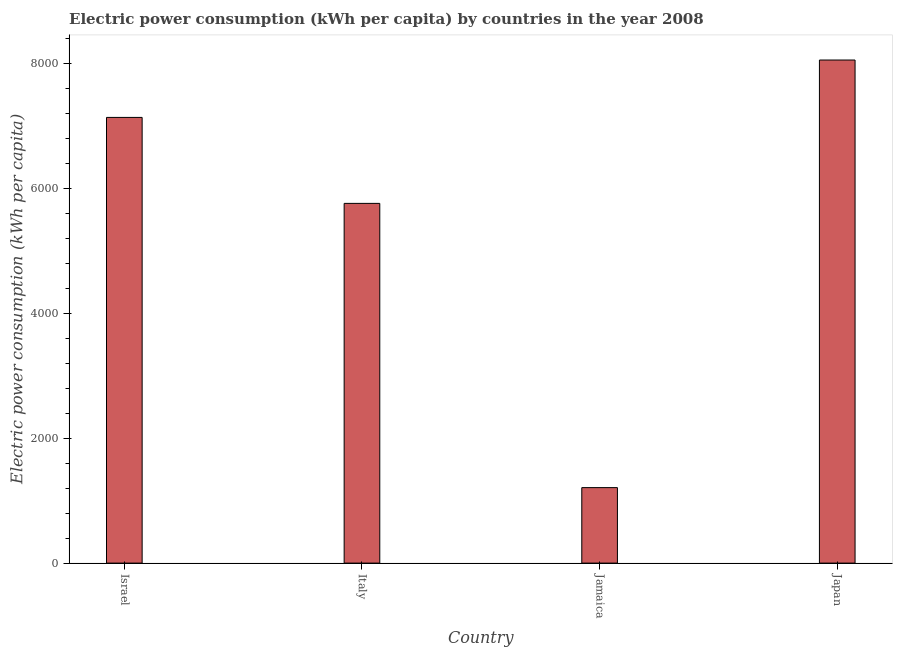Does the graph contain grids?
Keep it short and to the point. No. What is the title of the graph?
Give a very brief answer. Electric power consumption (kWh per capita) by countries in the year 2008. What is the label or title of the Y-axis?
Ensure brevity in your answer.  Electric power consumption (kWh per capita). What is the electric power consumption in Japan?
Keep it short and to the point. 8052.58. Across all countries, what is the maximum electric power consumption?
Provide a succinct answer. 8052.58. Across all countries, what is the minimum electric power consumption?
Offer a terse response. 1208.11. In which country was the electric power consumption minimum?
Provide a short and direct response. Jamaica. What is the sum of the electric power consumption?
Give a very brief answer. 2.22e+04. What is the difference between the electric power consumption in Israel and Italy?
Make the answer very short. 1376.06. What is the average electric power consumption per country?
Your answer should be compact. 5538.16. What is the median electric power consumption?
Offer a terse response. 6445.97. In how many countries, is the electric power consumption greater than 6400 kWh per capita?
Make the answer very short. 2. What is the ratio of the electric power consumption in Israel to that in Jamaica?
Your response must be concise. 5.91. Is the difference between the electric power consumption in Italy and Jamaica greater than the difference between any two countries?
Your answer should be compact. No. What is the difference between the highest and the second highest electric power consumption?
Offer a very short reply. 918.57. Is the sum of the electric power consumption in Israel and Japan greater than the maximum electric power consumption across all countries?
Keep it short and to the point. Yes. What is the difference between the highest and the lowest electric power consumption?
Ensure brevity in your answer.  6844.46. In how many countries, is the electric power consumption greater than the average electric power consumption taken over all countries?
Your answer should be very brief. 3. How many bars are there?
Your response must be concise. 4. Are all the bars in the graph horizontal?
Give a very brief answer. No. How many countries are there in the graph?
Offer a very short reply. 4. What is the difference between two consecutive major ticks on the Y-axis?
Give a very brief answer. 2000. What is the Electric power consumption (kWh per capita) of Israel?
Keep it short and to the point. 7134. What is the Electric power consumption (kWh per capita) in Italy?
Provide a short and direct response. 5757.94. What is the Electric power consumption (kWh per capita) in Jamaica?
Keep it short and to the point. 1208.11. What is the Electric power consumption (kWh per capita) of Japan?
Give a very brief answer. 8052.58. What is the difference between the Electric power consumption (kWh per capita) in Israel and Italy?
Provide a short and direct response. 1376.06. What is the difference between the Electric power consumption (kWh per capita) in Israel and Jamaica?
Offer a very short reply. 5925.89. What is the difference between the Electric power consumption (kWh per capita) in Israel and Japan?
Give a very brief answer. -918.57. What is the difference between the Electric power consumption (kWh per capita) in Italy and Jamaica?
Offer a terse response. 4549.83. What is the difference between the Electric power consumption (kWh per capita) in Italy and Japan?
Ensure brevity in your answer.  -2294.63. What is the difference between the Electric power consumption (kWh per capita) in Jamaica and Japan?
Your answer should be very brief. -6844.46. What is the ratio of the Electric power consumption (kWh per capita) in Israel to that in Italy?
Your answer should be very brief. 1.24. What is the ratio of the Electric power consumption (kWh per capita) in Israel to that in Jamaica?
Offer a very short reply. 5.91. What is the ratio of the Electric power consumption (kWh per capita) in Israel to that in Japan?
Offer a terse response. 0.89. What is the ratio of the Electric power consumption (kWh per capita) in Italy to that in Jamaica?
Offer a very short reply. 4.77. What is the ratio of the Electric power consumption (kWh per capita) in Italy to that in Japan?
Provide a succinct answer. 0.71. 